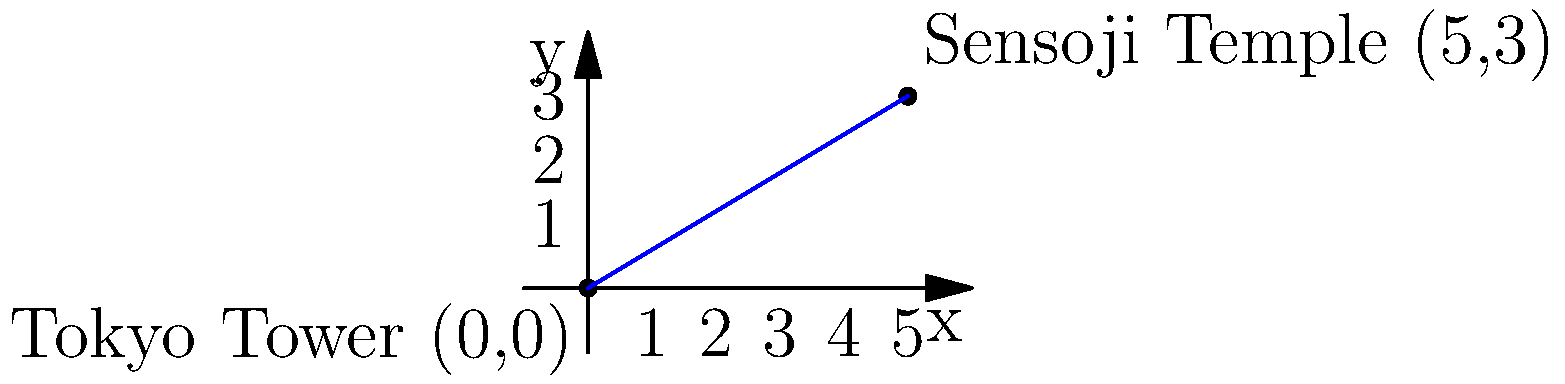As you prepare for your move to Tokyo, you're studying a map of the city's famous landmarks. On a coordinate plane, Tokyo Tower is located at (0,0) and Sensoji Temple is at (5,3). What is the slope of the line connecting these two attractions? To find the slope of the line connecting Tokyo Tower and Sensoji Temple, we can use the slope formula:

$$ \text{slope} = \frac{y_2 - y_1}{x_2 - x_1} $$

Where $(x_1, y_1)$ is the coordinate of Tokyo Tower (0,0) and $(x_2, y_2)$ is the coordinate of Sensoji Temple (5,3).

Let's substitute these values into the formula:

$$ \text{slope} = \frac{3 - 0}{5 - 0} = \frac{3}{5} $$

Simplifying the fraction:

$$ \text{slope} = \frac{3}{5} = 0.6 $$

Therefore, the slope of the line connecting Tokyo Tower and Sensoji Temple is $\frac{3}{5}$ or 0.6.
Answer: $\frac{3}{5}$ or 0.6 